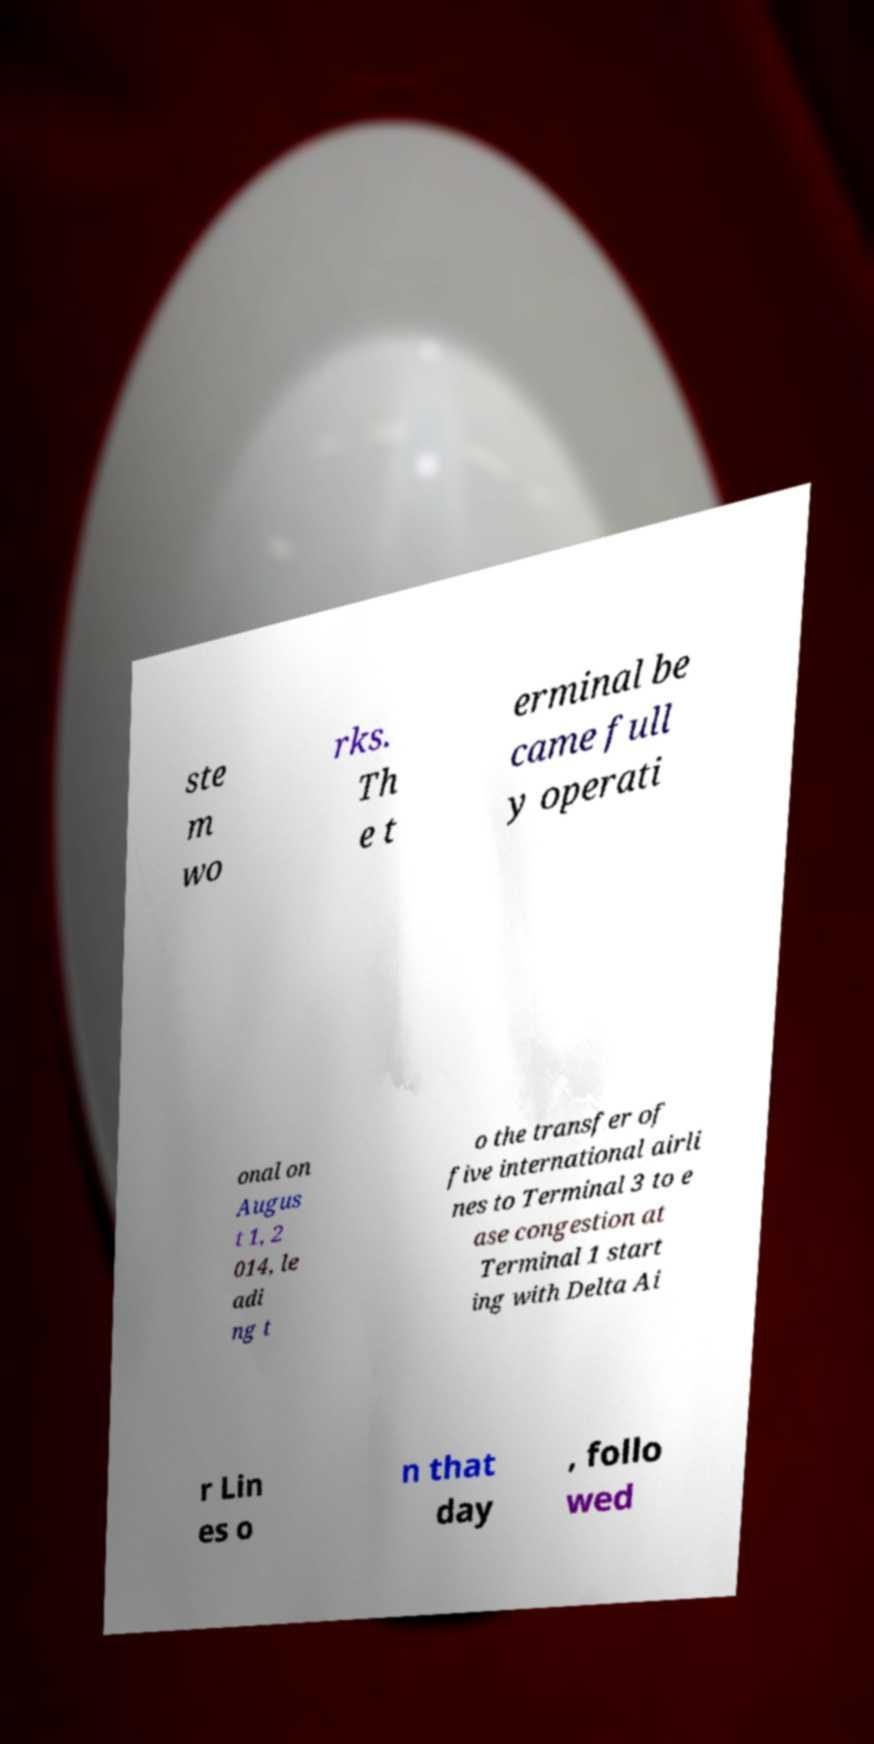There's text embedded in this image that I need extracted. Can you transcribe it verbatim? ste m wo rks. Th e t erminal be came full y operati onal on Augus t 1, 2 014, le adi ng t o the transfer of five international airli nes to Terminal 3 to e ase congestion at Terminal 1 start ing with Delta Ai r Lin es o n that day , follo wed 